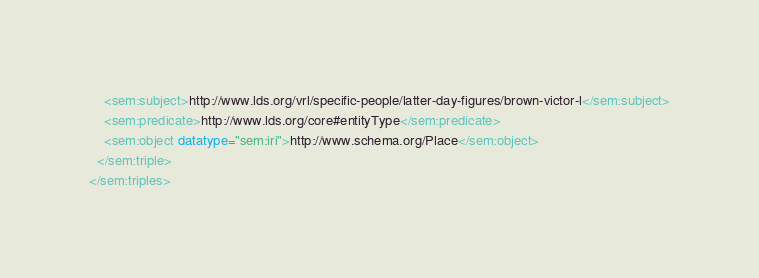<code> <loc_0><loc_0><loc_500><loc_500><_XML_>    <sem:subject>http://www.lds.org/vrl/specific-people/latter-day-figures/brown-victor-l</sem:subject>
    <sem:predicate>http://www.lds.org/core#entityType</sem:predicate>
    <sem:object datatype="sem:iri">http://www.schema.org/Place</sem:object>
  </sem:triple>
</sem:triples>
</code> 